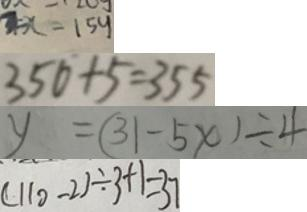<formula> <loc_0><loc_0><loc_500><loc_500>3 = x - 1 5 y 
 3 5 0 + 5 = 3 5 5 
 y = ( 3 1 - 5 x ) \div 4 
 ( 1 1 0 - 2 ) \div 3 + 1 = 3 7</formula> 